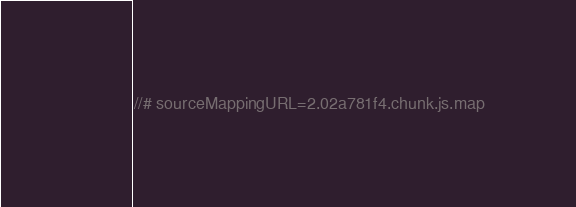Convert code to text. <code><loc_0><loc_0><loc_500><loc_500><_JavaScript_>//# sourceMappingURL=2.02a781f4.chunk.js.map</code> 